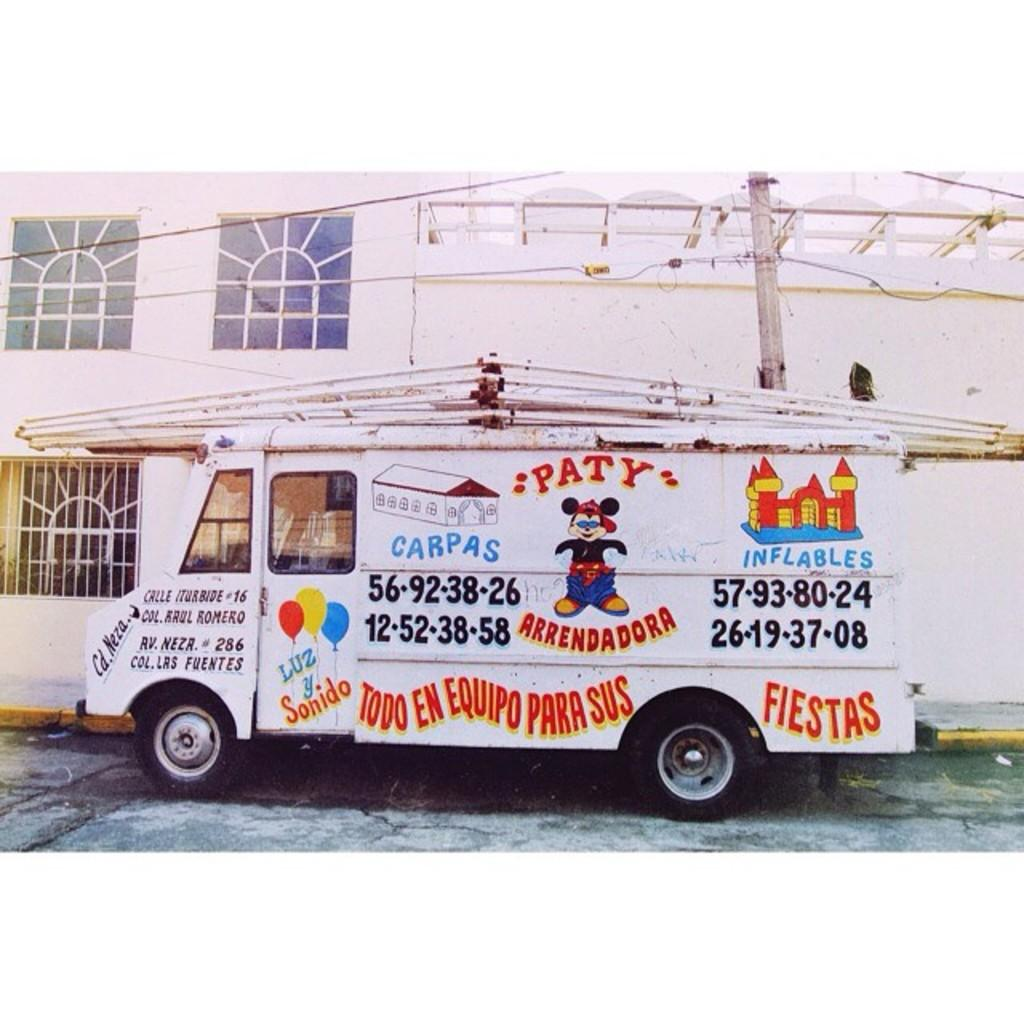<image>
Give a short and clear explanation of the subsequent image. A company box truck with the company name of Paty Arrendadora and a Mickey Mouse character. 